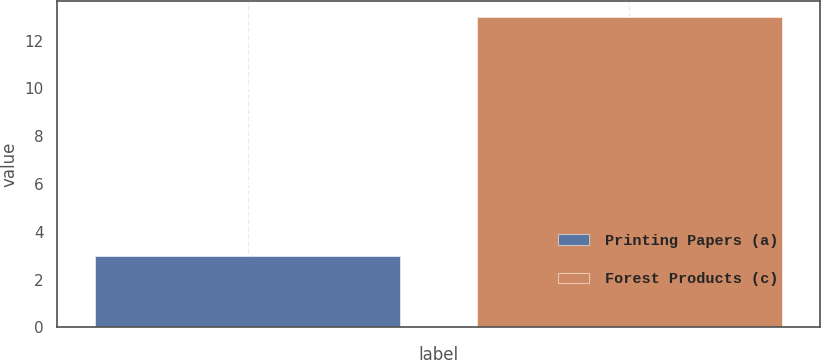<chart> <loc_0><loc_0><loc_500><loc_500><bar_chart><fcel>Printing Papers (a)<fcel>Forest Products (c)<nl><fcel>3<fcel>13<nl></chart> 